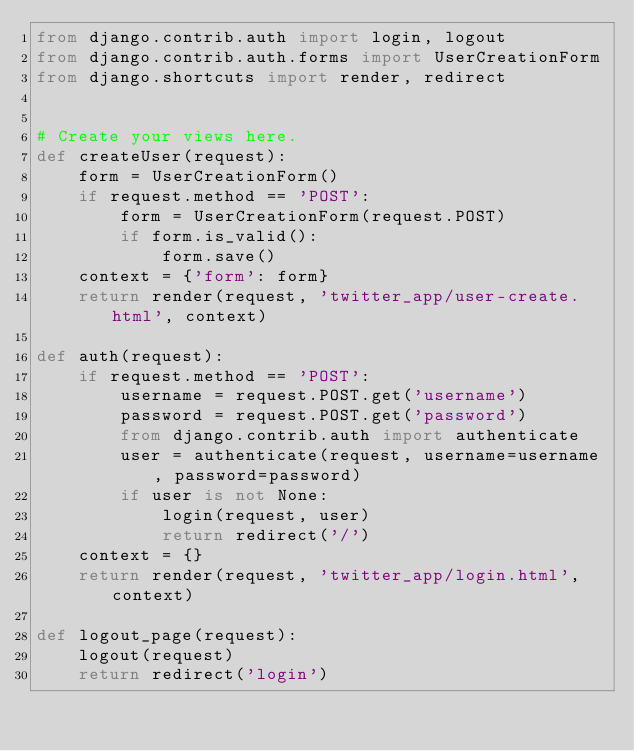Convert code to text. <code><loc_0><loc_0><loc_500><loc_500><_Python_>from django.contrib.auth import login, logout
from django.contrib.auth.forms import UserCreationForm
from django.shortcuts import render, redirect


# Create your views here.
def createUser(request):
    form = UserCreationForm()
    if request.method == 'POST':
        form = UserCreationForm(request.POST)
        if form.is_valid():
            form.save()
    context = {'form': form}
    return render(request, 'twitter_app/user-create.html', context)

def auth(request):
    if request.method == 'POST':
        username = request.POST.get('username')
        password = request.POST.get('password')
        from django.contrib.auth import authenticate
        user = authenticate(request, username=username, password=password)
        if user is not None:
            login(request, user)
            return redirect('/')
    context = {}
    return render(request, 'twitter_app/login.html', context)

def logout_page(request):
    logout(request)
    return redirect('login')</code> 